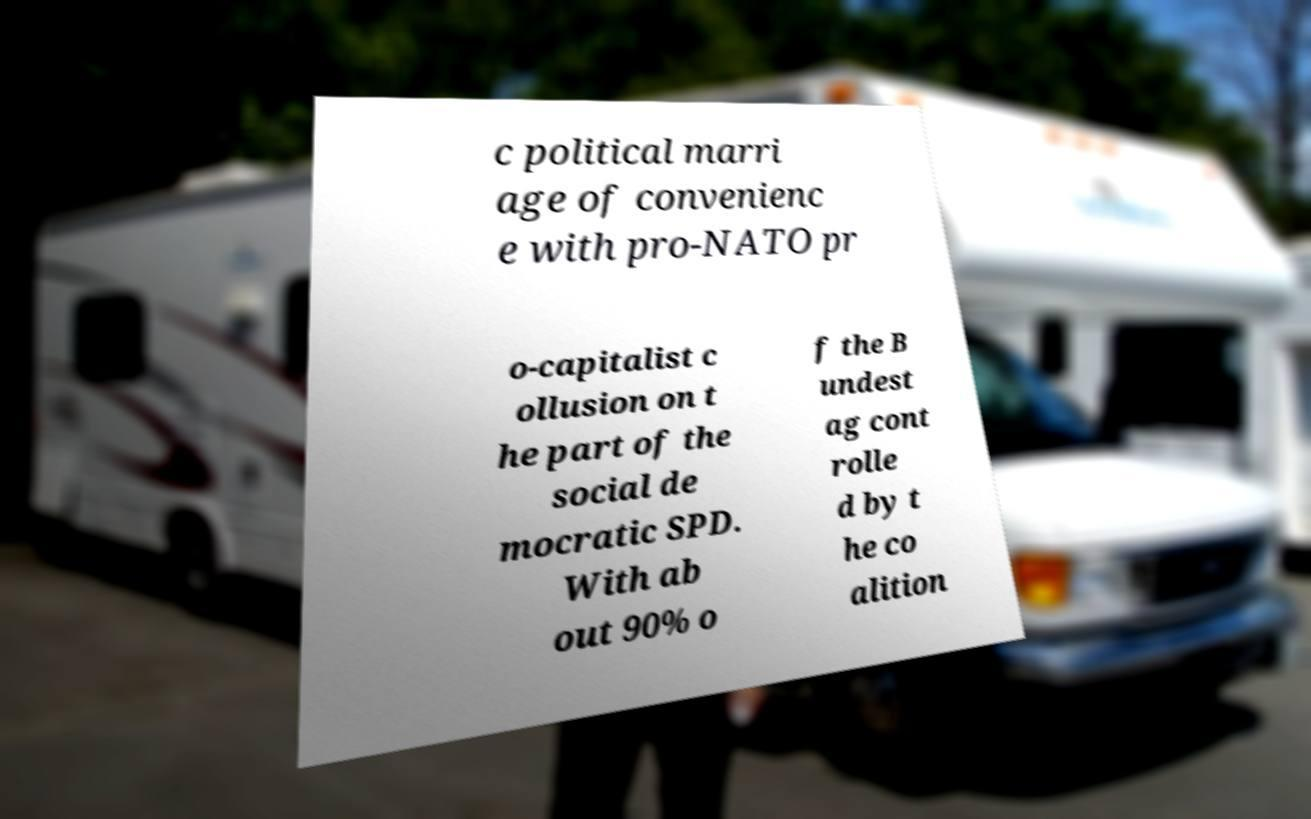I need the written content from this picture converted into text. Can you do that? c political marri age of convenienc e with pro-NATO pr o-capitalist c ollusion on t he part of the social de mocratic SPD. With ab out 90% o f the B undest ag cont rolle d by t he co alition 